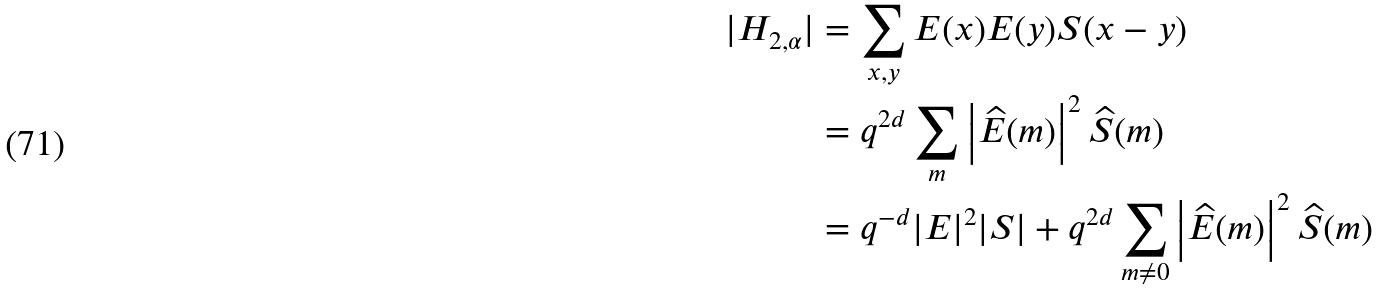Convert formula to latex. <formula><loc_0><loc_0><loc_500><loc_500>| H _ { 2 , \alpha } | & = \sum _ { x , y } E ( x ) E ( y ) S ( x - y ) \\ & = q ^ { 2 d } \sum _ { m } \left | \widehat { E } ( m ) \right | ^ { 2 } \widehat { S } ( m ) \\ & = q ^ { - d } | E | ^ { 2 } | S | + q ^ { 2 d } \sum _ { m \neq 0 } \left | \widehat { E } ( m ) \right | ^ { 2 } \widehat { S } ( m )</formula> 